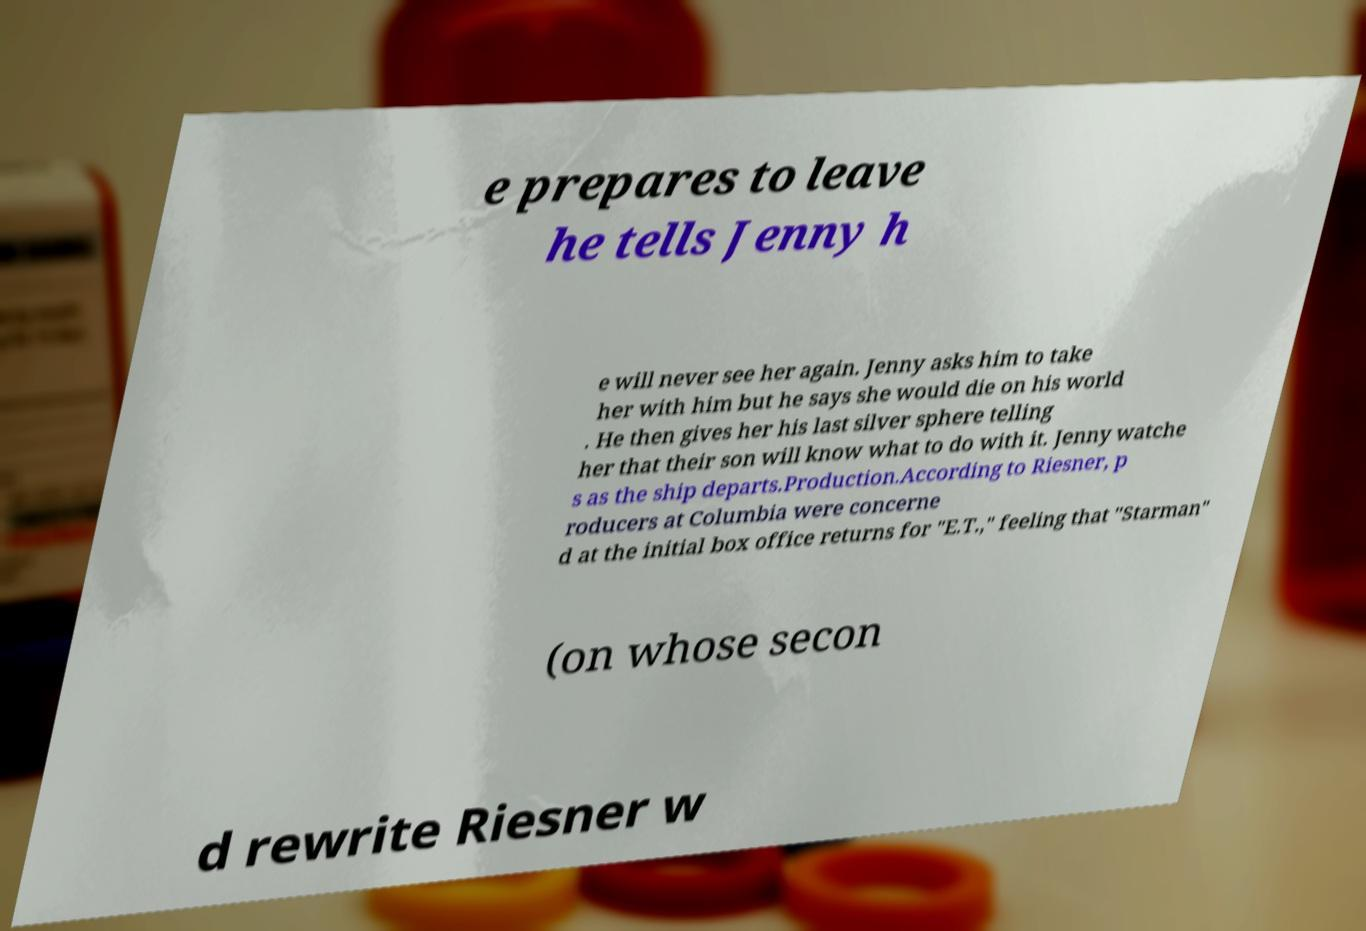Can you read and provide the text displayed in the image?This photo seems to have some interesting text. Can you extract and type it out for me? e prepares to leave he tells Jenny h e will never see her again. Jenny asks him to take her with him but he says she would die on his world . He then gives her his last silver sphere telling her that their son will know what to do with it. Jenny watche s as the ship departs.Production.According to Riesner, p roducers at Columbia were concerne d at the initial box office returns for "E.T.," feeling that "Starman" (on whose secon d rewrite Riesner w 